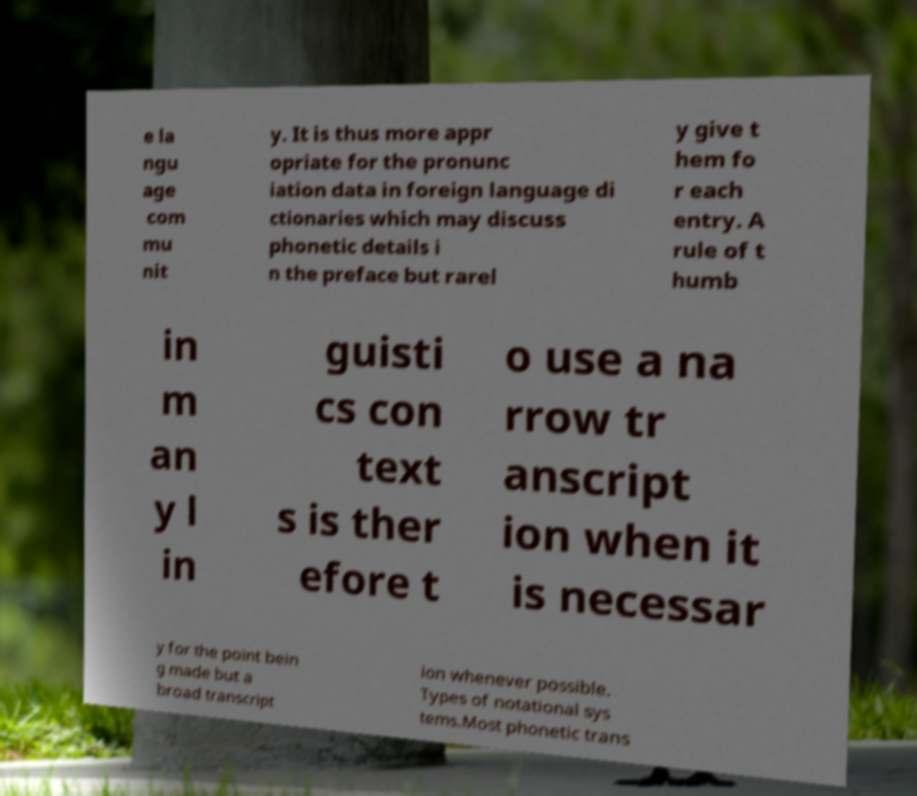There's text embedded in this image that I need extracted. Can you transcribe it verbatim? e la ngu age com mu nit y. It is thus more appr opriate for the pronunc iation data in foreign language di ctionaries which may discuss phonetic details i n the preface but rarel y give t hem fo r each entry. A rule of t humb in m an y l in guisti cs con text s is ther efore t o use a na rrow tr anscript ion when it is necessar y for the point bein g made but a broad transcript ion whenever possible. Types of notational sys tems.Most phonetic trans 